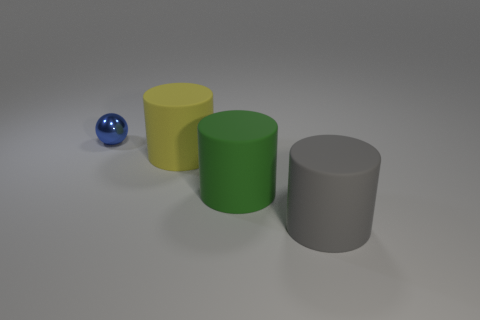What number of matte things are either green cylinders or small blue cylinders?
Offer a terse response. 1. Are there any other things that have the same color as the small shiny thing?
Give a very brief answer. No. Is the shape of the thing left of the yellow matte cylinder the same as the big thing that is right of the green cylinder?
Your answer should be compact. No. How many things are either tiny red rubber blocks or gray things that are right of the big green matte cylinder?
Offer a terse response. 1. How many other objects are there of the same size as the sphere?
Your answer should be very brief. 0. Do the object that is in front of the green rubber thing and the thing left of the large yellow cylinder have the same material?
Your answer should be compact. No. What number of small blue shiny spheres are behind the tiny metal ball?
Ensure brevity in your answer.  0. What number of yellow objects are either big matte things or large metal things?
Offer a terse response. 1. What is the material of the yellow cylinder that is the same size as the green rubber object?
Offer a terse response. Rubber. The thing that is left of the large green matte cylinder and on the right side of the small blue ball has what shape?
Provide a short and direct response. Cylinder. 